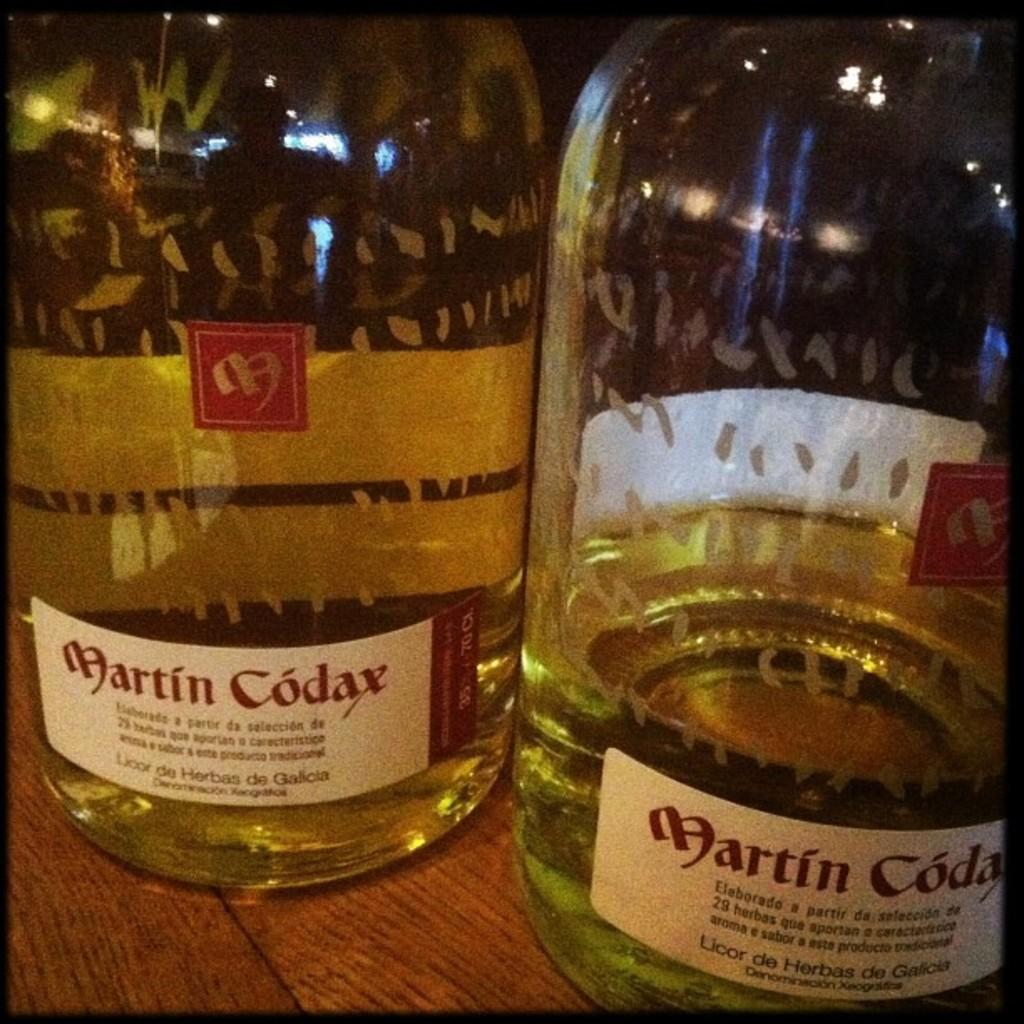Provide a one-sentence caption for the provided image. One and half liquid contents of martin codax liquor in two bottles are placed on a table. 